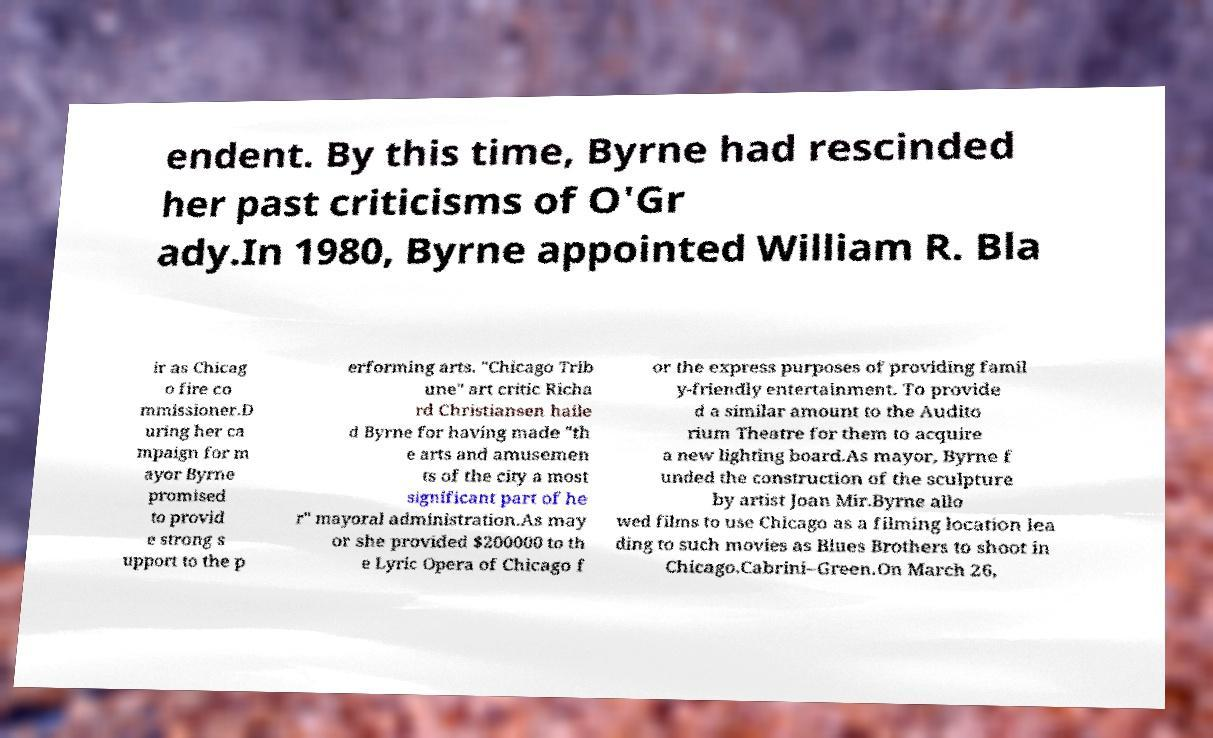Can you read and provide the text displayed in the image?This photo seems to have some interesting text. Can you extract and type it out for me? endent. By this time, Byrne had rescinded her past criticisms of O'Gr ady.In 1980, Byrne appointed William R. Bla ir as Chicag o fire co mmissioner.D uring her ca mpaign for m ayor Byrne promised to provid e strong s upport to the p erforming arts. "Chicago Trib une" art critic Richa rd Christiansen haile d Byrne for having made "th e arts and amusemen ts of the city a most significant part of he r" mayoral administration.As may or she provided $200000 to th e Lyric Opera of Chicago f or the express purposes of providing famil y-friendly entertainment. To provide d a similar amount to the Audito rium Theatre for them to acquire a new lighting board.As mayor, Byrne f unded the construction of the sculpture by artist Joan Mir.Byrne allo wed films to use Chicago as a filming location lea ding to such movies as Blues Brothers to shoot in Chicago.Cabrini–Green.On March 26, 